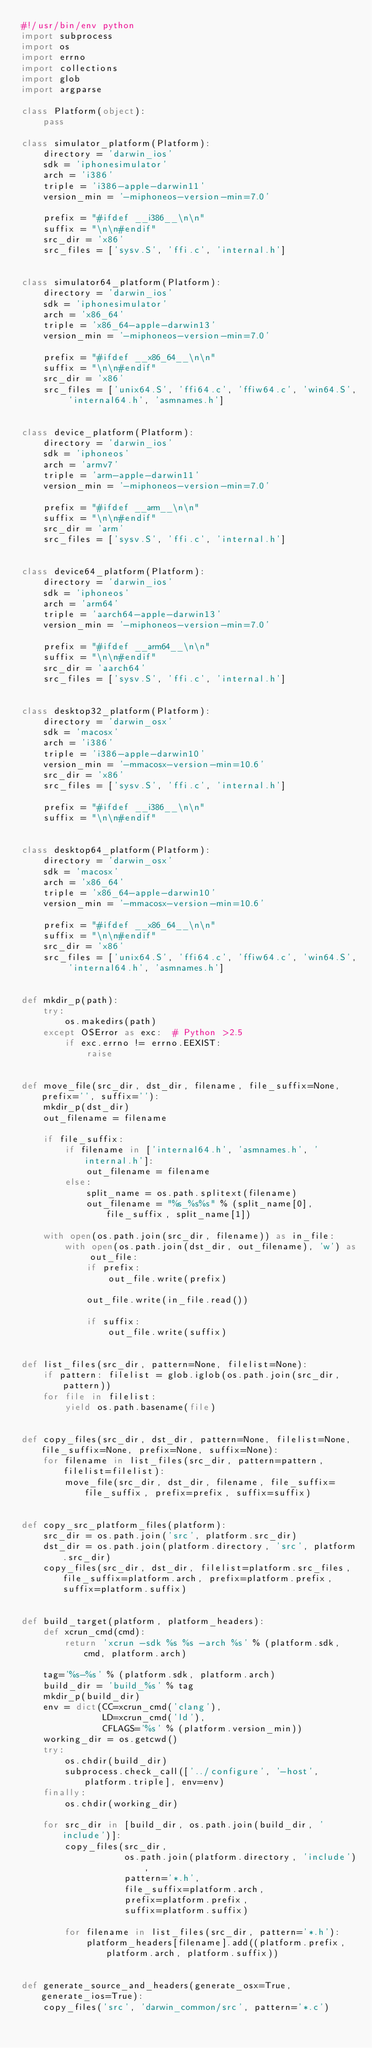Convert code to text. <code><loc_0><loc_0><loc_500><loc_500><_Python_>#!/usr/bin/env python
import subprocess
import os
import errno
import collections
import glob
import argparse

class Platform(object):
    pass

class simulator_platform(Platform):
    directory = 'darwin_ios'
    sdk = 'iphonesimulator'
    arch = 'i386'
    triple = 'i386-apple-darwin11'
    version_min = '-miphoneos-version-min=7.0'

    prefix = "#ifdef __i386__\n\n"
    suffix = "\n\n#endif"
    src_dir = 'x86'
    src_files = ['sysv.S', 'ffi.c', 'internal.h']


class simulator64_platform(Platform):
    directory = 'darwin_ios'
    sdk = 'iphonesimulator'
    arch = 'x86_64'
    triple = 'x86_64-apple-darwin13'
    version_min = '-miphoneos-version-min=7.0'

    prefix = "#ifdef __x86_64__\n\n"
    suffix = "\n\n#endif"
    src_dir = 'x86'
    src_files = ['unix64.S', 'ffi64.c', 'ffiw64.c', 'win64.S', 'internal64.h', 'asmnames.h']


class device_platform(Platform):
    directory = 'darwin_ios'
    sdk = 'iphoneos'
    arch = 'armv7'
    triple = 'arm-apple-darwin11'
    version_min = '-miphoneos-version-min=7.0'

    prefix = "#ifdef __arm__\n\n"
    suffix = "\n\n#endif"
    src_dir = 'arm'
    src_files = ['sysv.S', 'ffi.c', 'internal.h']


class device64_platform(Platform):
    directory = 'darwin_ios'
    sdk = 'iphoneos'
    arch = 'arm64'
    triple = 'aarch64-apple-darwin13'
    version_min = '-miphoneos-version-min=7.0'

    prefix = "#ifdef __arm64__\n\n"
    suffix = "\n\n#endif"
    src_dir = 'aarch64'
    src_files = ['sysv.S', 'ffi.c', 'internal.h']


class desktop32_platform(Platform):
    directory = 'darwin_osx'
    sdk = 'macosx'
    arch = 'i386'
    triple = 'i386-apple-darwin10'
    version_min = '-mmacosx-version-min=10.6'
    src_dir = 'x86'
    src_files = ['sysv.S', 'ffi.c', 'internal.h']

    prefix = "#ifdef __i386__\n\n"
    suffix = "\n\n#endif"


class desktop64_platform(Platform):
    directory = 'darwin_osx'
    sdk = 'macosx'
    arch = 'x86_64'
    triple = 'x86_64-apple-darwin10'
    version_min = '-mmacosx-version-min=10.6'

    prefix = "#ifdef __x86_64__\n\n"
    suffix = "\n\n#endif"
    src_dir = 'x86'
    src_files = ['unix64.S', 'ffi64.c', 'ffiw64.c', 'win64.S', 'internal64.h', 'asmnames.h']


def mkdir_p(path):
    try:
        os.makedirs(path)
    except OSError as exc:  # Python >2.5
        if exc.errno != errno.EEXIST:
            raise


def move_file(src_dir, dst_dir, filename, file_suffix=None, prefix='', suffix=''):
    mkdir_p(dst_dir)
    out_filename = filename

    if file_suffix:
        if filename in ['internal64.h', 'asmnames.h', 'internal.h']:
            out_filename = filename
        else:
            split_name = os.path.splitext(filename)
            out_filename = "%s_%s%s" % (split_name[0], file_suffix, split_name[1])

    with open(os.path.join(src_dir, filename)) as in_file:
        with open(os.path.join(dst_dir, out_filename), 'w') as out_file:
            if prefix:
                out_file.write(prefix)

            out_file.write(in_file.read())

            if suffix:
                out_file.write(suffix)


def list_files(src_dir, pattern=None, filelist=None):
    if pattern: filelist = glob.iglob(os.path.join(src_dir, pattern))
    for file in filelist:
        yield os.path.basename(file)


def copy_files(src_dir, dst_dir, pattern=None, filelist=None, file_suffix=None, prefix=None, suffix=None):
    for filename in list_files(src_dir, pattern=pattern, filelist=filelist):
        move_file(src_dir, dst_dir, filename, file_suffix=file_suffix, prefix=prefix, suffix=suffix)


def copy_src_platform_files(platform):
    src_dir = os.path.join('src', platform.src_dir)
    dst_dir = os.path.join(platform.directory, 'src', platform.src_dir)
    copy_files(src_dir, dst_dir, filelist=platform.src_files, file_suffix=platform.arch, prefix=platform.prefix, suffix=platform.suffix)


def build_target(platform, platform_headers):
    def xcrun_cmd(cmd):
        return 'xcrun -sdk %s %s -arch %s' % (platform.sdk, cmd, platform.arch)

    tag='%s-%s' % (platform.sdk, platform.arch)
    build_dir = 'build_%s' % tag
    mkdir_p(build_dir)
    env = dict(CC=xcrun_cmd('clang'),
               LD=xcrun_cmd('ld'),
               CFLAGS='%s' % (platform.version_min))
    working_dir = os.getcwd()
    try:
        os.chdir(build_dir)
        subprocess.check_call(['../configure', '-host', platform.triple], env=env)
    finally:
        os.chdir(working_dir)

    for src_dir in [build_dir, os.path.join(build_dir, 'include')]:
        copy_files(src_dir,
                   os.path.join(platform.directory, 'include'),
                   pattern='*.h',
                   file_suffix=platform.arch,
                   prefix=platform.prefix,
                   suffix=platform.suffix)

        for filename in list_files(src_dir, pattern='*.h'):
            platform_headers[filename].add((platform.prefix, platform.arch, platform.suffix))


def generate_source_and_headers(generate_osx=True, generate_ios=True):
    copy_files('src', 'darwin_common/src', pattern='*.c')</code> 